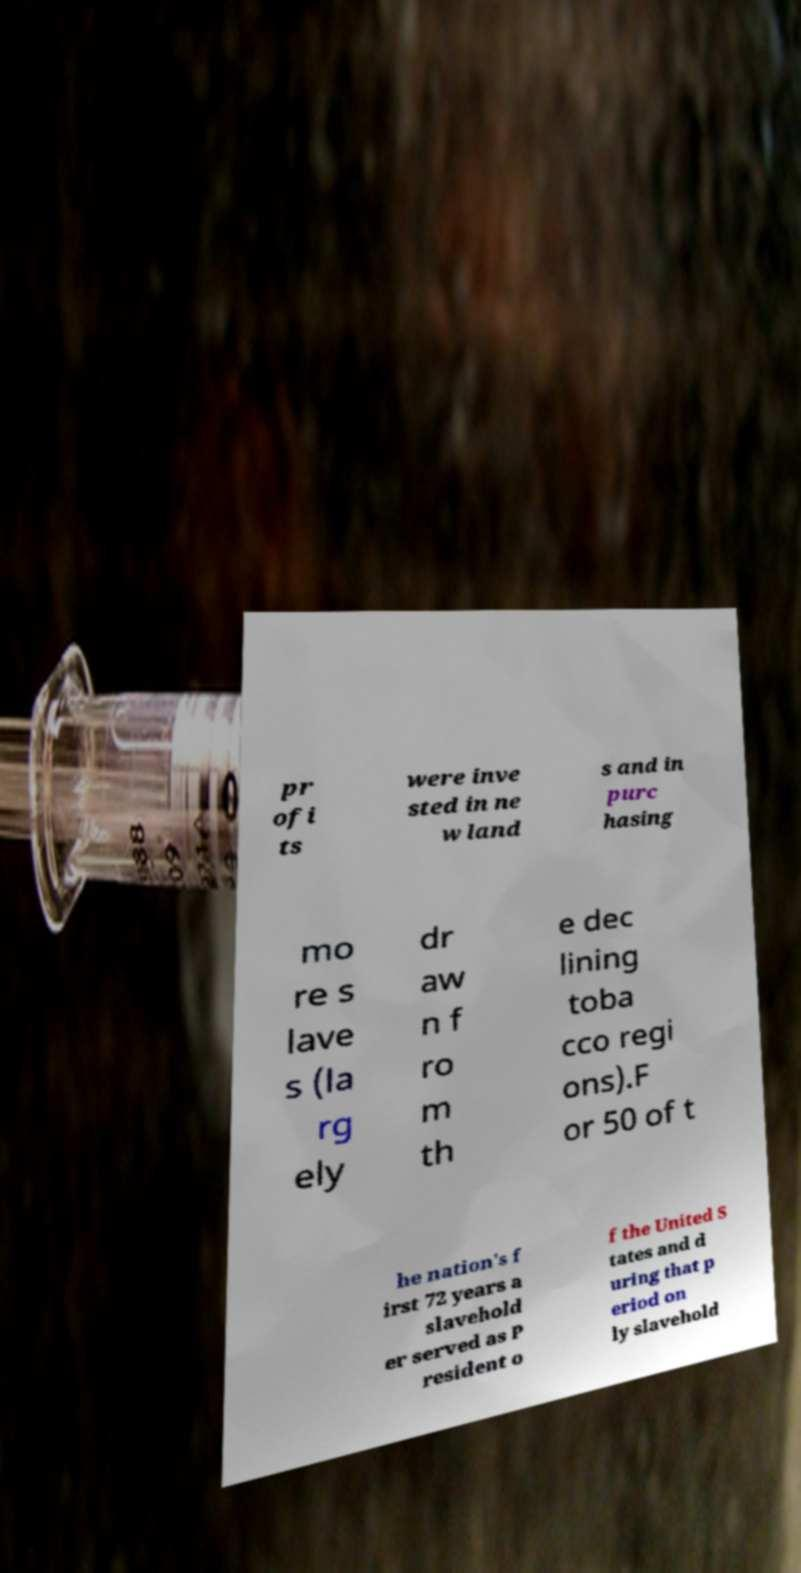Could you assist in decoding the text presented in this image and type it out clearly? pr ofi ts were inve sted in ne w land s and in purc hasing mo re s lave s (la rg ely dr aw n f ro m th e dec lining toba cco regi ons).F or 50 of t he nation's f irst 72 years a slavehold er served as P resident o f the United S tates and d uring that p eriod on ly slavehold 